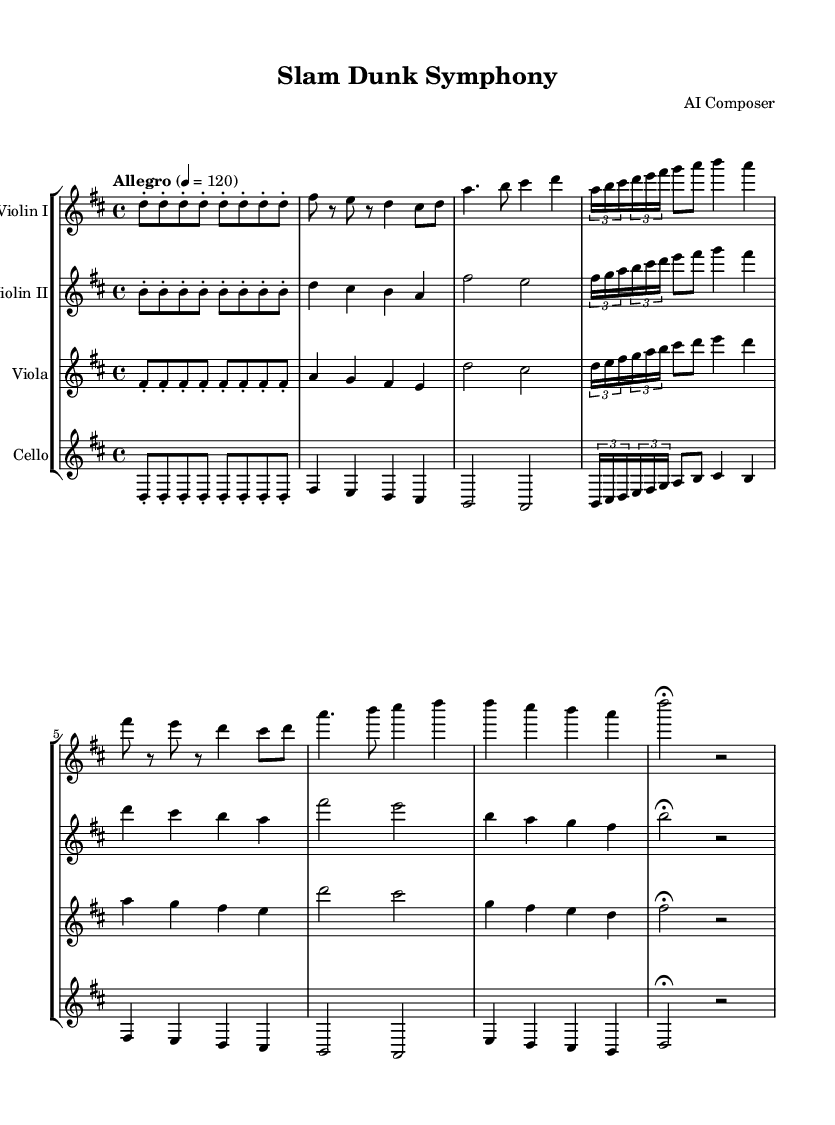What is the key signature of this music? The key signature is indicated by the presence of two sharps (F# and C#) at the beginning of the score, which is characteristic of D major.
Answer: D major What is the time signature of the piece? The time signature is located at the beginning of the score, denoted by the numbers 4/4, meaning there are four beats in each measure.
Answer: 4/4 What is the tempo marking for this symphony? The tempo marking is shown at the beginning of the score stating "Allegro" with a metronome marking of "4 = 120," indicating the speed of the music.
Answer: Allegro Which theme represents the dribbling portion of the piece? The dribbling is represented in the part labeled "Theme A," which includes the notes fis, e, and d as the melodic movement, illustrating a rhythmic quality.
Answer: Theme A What is the final section of the symphony called? The last section of the score is labeled as "Coda," signaling the concluding part of the composition and bringing resolution to the piece.
Answer: Coda How many instruments are present in this score? The number of staves in the score indicates the instruments being used; here, there are four staves, each representing one instrument: Violin I, Violin II, Viola, and Cello.
Answer: Four What does the term "fermata" indicate in this sheet music? The "fermata" symbol is used to indicate a pause or hold on the note for an extended duration, allowing for expressive timing before moving on with the music.
Answer: Hold 